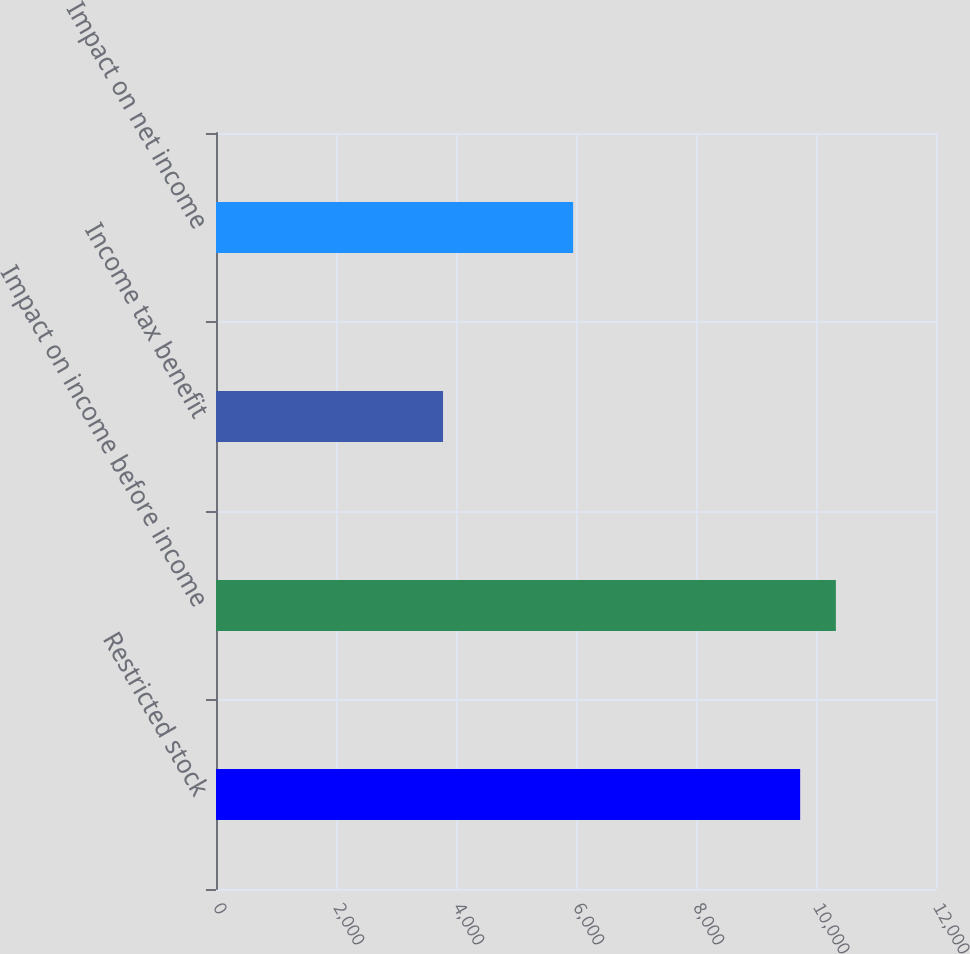Convert chart to OTSL. <chart><loc_0><loc_0><loc_500><loc_500><bar_chart><fcel>Restricted stock<fcel>Impact on income before income<fcel>Income tax benefit<fcel>Impact on net income<nl><fcel>9736<fcel>10331.2<fcel>3784<fcel>5952<nl></chart> 